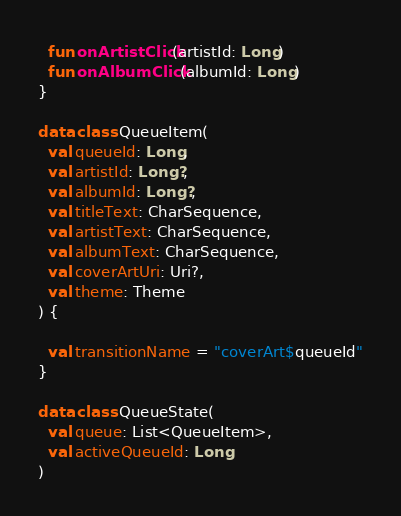<code> <loc_0><loc_0><loc_500><loc_500><_Kotlin_>
  fun onArtistClick(artistId: Long)
  fun onAlbumClick(albumId: Long)
}

data class QueueItem(
  val queueId: Long,
  val artistId: Long?,
  val albumId: Long?,
  val titleText: CharSequence,
  val artistText: CharSequence,
  val albumText: CharSequence,
  val coverArtUri: Uri?,
  val theme: Theme
) {

  val transitionName = "coverArt$queueId"
}

data class QueueState(
  val queue: List<QueueItem>,
  val activeQueueId: Long
)</code> 